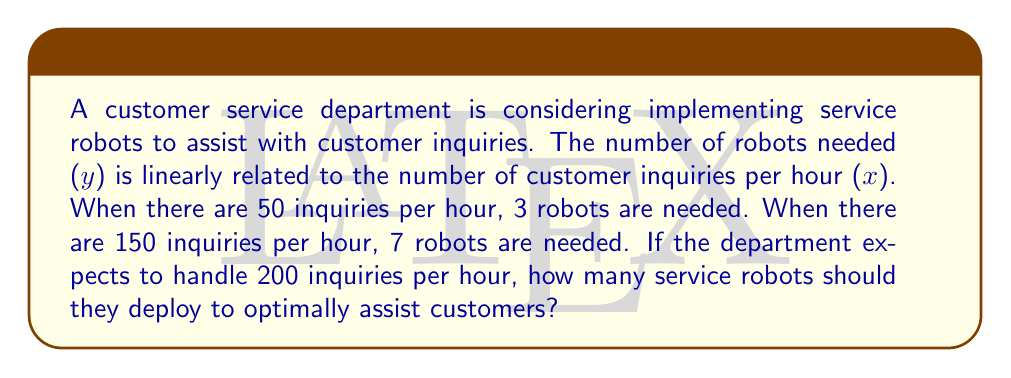What is the answer to this math problem? To solve this problem, we need to follow these steps:

1. Find the linear function that relates the number of robots (y) to the number of inquiries per hour (x).

2. Use the given information to create two points: (50, 3) and (150, 7).

3. Calculate the slope (m) of the line:
   $$m = \frac{y_2 - y_1}{x_2 - x_1} = \frac{7 - 3}{150 - 50} = \frac{4}{100} = 0.04$$

4. Use the point-slope form of a line to create the equation:
   $$y - y_1 = m(x - x_1)$$
   $$y - 3 = 0.04(x - 50)$$

5. Simplify to get the slope-intercept form:
   $$y = 0.04x - 2 + 3$$
   $$y = 0.04x + 1$$

6. Now that we have the linear function, we can plug in x = 200 to find the optimal number of robots:
   $$y = 0.04(200) + 1$$
   $$y = 8 + 1 = 9$$

Therefore, the department should deploy 9 service robots to optimally assist customers when handling 200 inquiries per hour.
Answer: 9 service robots 